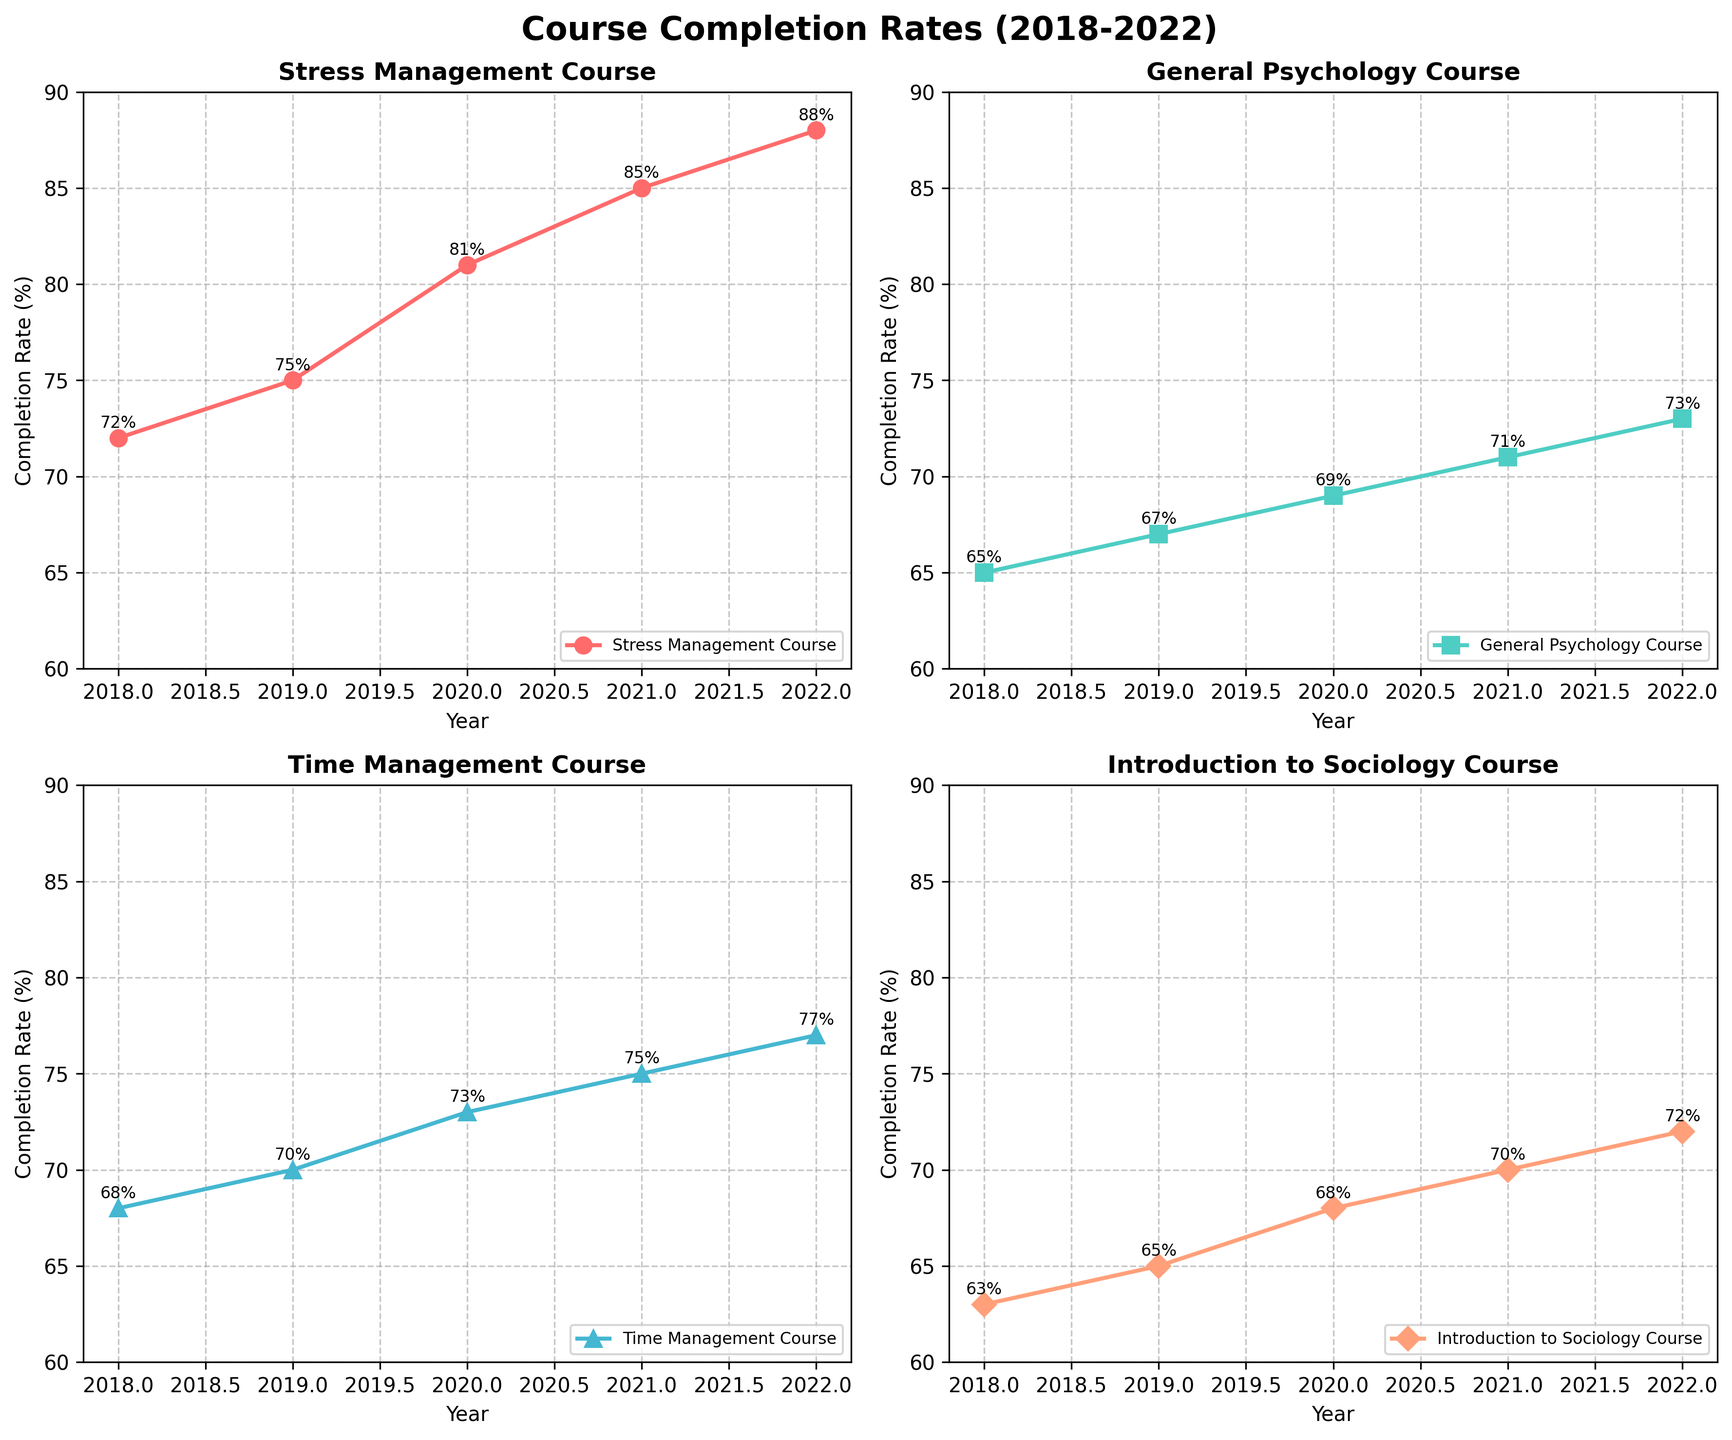What is the title of the plot? The title is typically displayed at the top of the figure. In this case, the code specifies the title as "Course Completion Rates (2018-2022)" to provide context about what the subplots represent.
Answer: Course Completion Rates (2018-2022) What is the completion rate for the Stress Management Course in 2022? To find the completion rate for the Stress Management Course in 2022, look at the subplot labeled "Stress Management Course" and find the data point corresponding to 2022. According to the data, it is 88%.
Answer: 88% Which course had the highest completion rate in 2019 and what was it? To determine the course with the highest completion rate in 2019, look for the year 2019 in all subplots. The rates are Stress Management Course: 75%, General Psychology Course: 67%, Time Management Course: 70%, Introduction to Sociology Course: 65%. The Stress Management Course had the highest rate with 75%.
Answer: Stress Management Course, 75% What is the average completion rate for Time Management Course over the years? To calculate the average, add the completion rates from 2018 to 2022 and divide by the number of years. The rates are 68, 70, 73, 75, 77. Summing these gives 363, and dividing by 5 gives 72.6.
Answer: 72.6% How much did the completion rate for the General Psychology Course increase from 2018 to 2022? To find the increase, subtract the completion rate in 2018 from the rate in 2022 for the General Psychology Course. The rates are 65% in 2018 and 73% in 2022. Therefore, the increase is 73 - 65 = 8%.
Answer: 8% Compare the completion rates of the Stress Management Course and Introduction to Sociology Course in 2020. Which one was higher and by how much? Check the rates for both courses in 2020. Stress Management Course: 81%, Introduction to Sociology Course: 68%. The Stress Management Course had a higher rate by 81 - 68 = 13%.
Answer: Stress Management Course, 13% Which course showed a steady increase in completion rates every year? To determine which course had a steady increase, examine each subplot to check the trend. The Stress Management Course shows a consistent rise from 2018 (72%) to 2022 (88%) without any decrease.
Answer: Stress Management Course What is the difference in completion rates for the Time Management Course between the years with the highest and lowest completion rates? Identify the highest and lowest rates for the Time Management Course. The highest is 77% in 2022 and the lowest is 68% in 2018. The difference is 77 - 68 = 9%.
Answer: 9% What trend do you observe for the General Psychology Course from 2018 to 2022? Looking at the subplot for the General Psychology Course, notice that the completion rate increases gradually from 65% in 2018 to 73% in 2022. This indicates a positive trend over the years.
Answer: Increasing trend Among the four courses, which one reached a completion rate of at least 80% first? In which year did this happen? Check the subplots to see when each course first reaches or exceeds an 80% completion rate. The Stress Management Course is the first to reach 81% in 2020.
Answer: Stress Management Course, 2020 